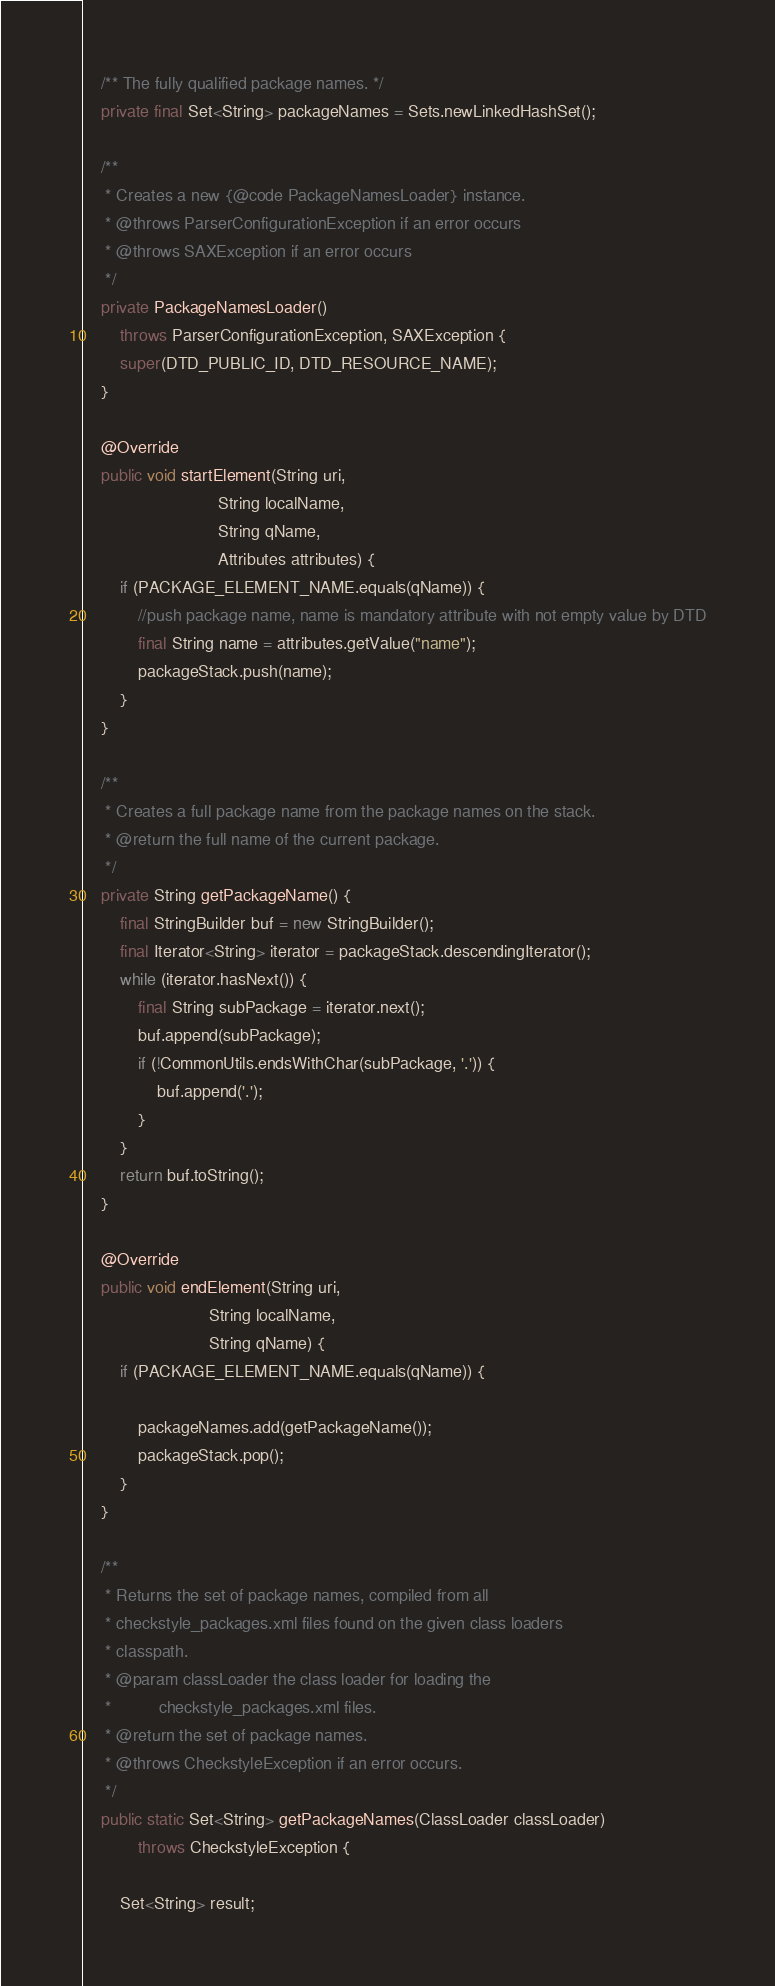<code> <loc_0><loc_0><loc_500><loc_500><_Java_>
    /** The fully qualified package names. */
    private final Set<String> packageNames = Sets.newLinkedHashSet();

    /**
     * Creates a new {@code PackageNamesLoader} instance.
     * @throws ParserConfigurationException if an error occurs
     * @throws SAXException if an error occurs
     */
    private PackageNamesLoader()
        throws ParserConfigurationException, SAXException {
        super(DTD_PUBLIC_ID, DTD_RESOURCE_NAME);
    }

    @Override
    public void startElement(String uri,
                             String localName,
                             String qName,
                             Attributes attributes) {
        if (PACKAGE_ELEMENT_NAME.equals(qName)) {
            //push package name, name is mandatory attribute with not empty value by DTD
            final String name = attributes.getValue("name");
            packageStack.push(name);
        }
    }

    /**
     * Creates a full package name from the package names on the stack.
     * @return the full name of the current package.
     */
    private String getPackageName() {
        final StringBuilder buf = new StringBuilder();
        final Iterator<String> iterator = packageStack.descendingIterator();
        while (iterator.hasNext()) {
            final String subPackage = iterator.next();
            buf.append(subPackage);
            if (!CommonUtils.endsWithChar(subPackage, '.')) {
                buf.append('.');
            }
        }
        return buf.toString();
    }

    @Override
    public void endElement(String uri,
                           String localName,
                           String qName) {
        if (PACKAGE_ELEMENT_NAME.equals(qName)) {

            packageNames.add(getPackageName());
            packageStack.pop();
        }
    }

    /**
     * Returns the set of package names, compiled from all
     * checkstyle_packages.xml files found on the given class loaders
     * classpath.
     * @param classLoader the class loader for loading the
     *          checkstyle_packages.xml files.
     * @return the set of package names.
     * @throws CheckstyleException if an error occurs.
     */
    public static Set<String> getPackageNames(ClassLoader classLoader)
            throws CheckstyleException {

        Set<String> result;</code> 